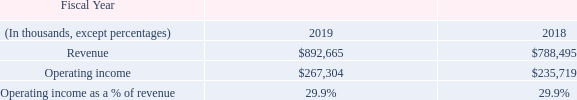Segment Product Revenue, Operating Income and Operating Income as a Percentage of Revenue
Infrastructure and Defense Products
IDP revenue increased $104.2 million, or 13.2%, in fiscal 2019, compared to fiscal 2018, primarily due to higher demand for our base station products.
IDP operating income increased $31.6 million, or 13.4%, in fiscal 2019, compared to fiscal 2018, primarily due to higher revenue, partially offset by lower gross margin (which was negatively impacted by lower factory utilization).
See Note 16 of the Notes to the Consolidated Financial Statements set forth in Part II, Item 8 of this report for a reconciliation of segment operating income to the consolidated operating income for fiscal years 2019, 2018 and 2017.
What are the respective revenue in 2018 and 2019?
Answer scale should be: thousand. $788,495, $892,665. What are the respective operating income in 2018 and 2019?
Answer scale should be: thousand. $235,719, $267,304. What are the respective operating income as a % of revenue in 2018 and 2019? 29.9%, 29.9%. What is the total revenue in 2018 and 2019?
Answer scale should be: thousand. ($788,495 + $892,665) 
Answer: 1681160. What is the value of the revenue in 2018 as a percentage of the revenue in 2019?
Answer scale should be: percent. ($788,495/$892,665) 
Answer: 88.33. What is the percentage change in the 2018 and 2019 revenue?
Answer scale should be: percent. (892,665 - 788,495)/788,495 
Answer: 13.21. 